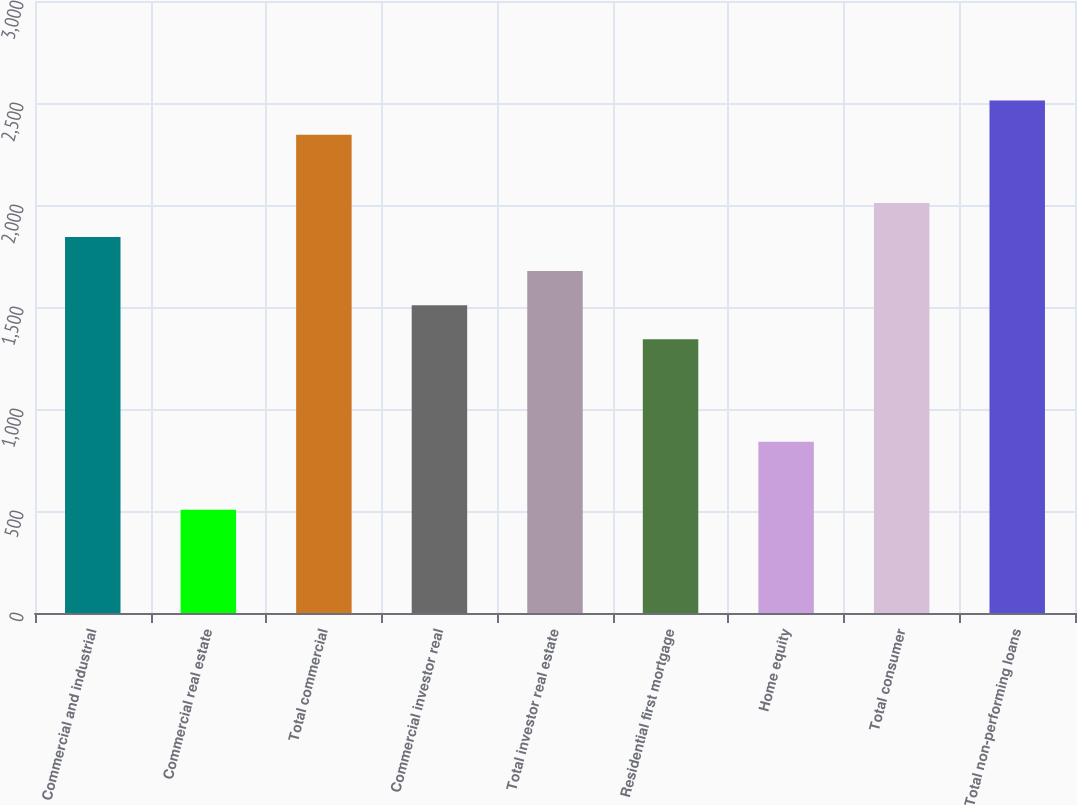Convert chart. <chart><loc_0><loc_0><loc_500><loc_500><bar_chart><fcel>Commercial and industrial<fcel>Commercial real estate<fcel>Total commercial<fcel>Commercial investor real<fcel>Total investor real estate<fcel>Residential first mortgage<fcel>Home equity<fcel>Total consumer<fcel>Total non-performing loans<nl><fcel>1843.2<fcel>505.6<fcel>2344.8<fcel>1508.8<fcel>1676<fcel>1341.6<fcel>840<fcel>2010.4<fcel>2512<nl></chart> 